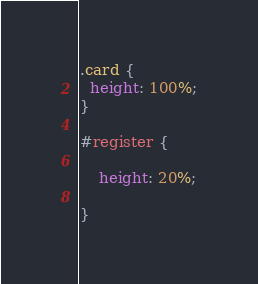Convert code to text. <code><loc_0><loc_0><loc_500><loc_500><_CSS_>.card {
  height: 100%;
}

#register {
    
    height: 20%;
    
}
</code> 